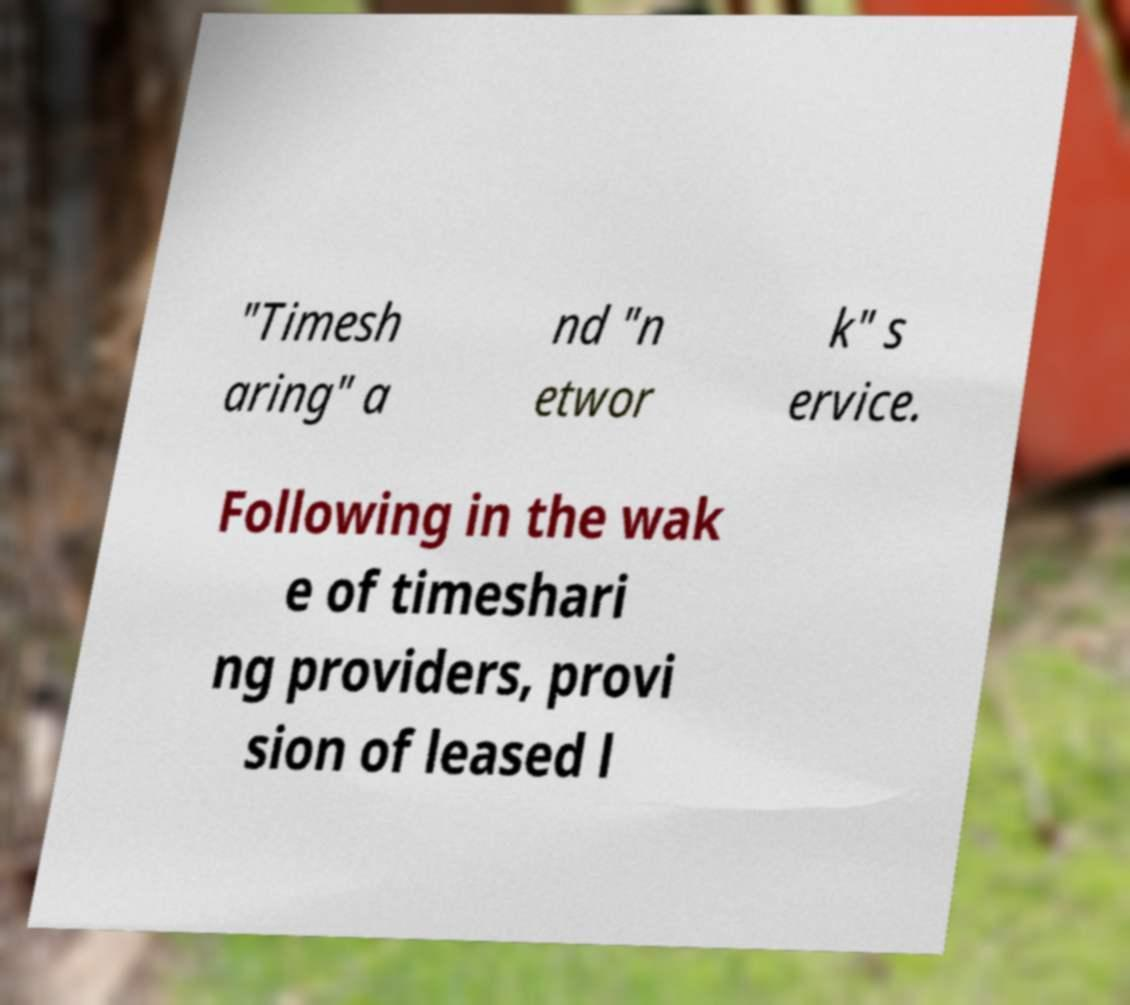Can you accurately transcribe the text from the provided image for me? "Timesh aring" a nd "n etwor k" s ervice. Following in the wak e of timeshari ng providers, provi sion of leased l 